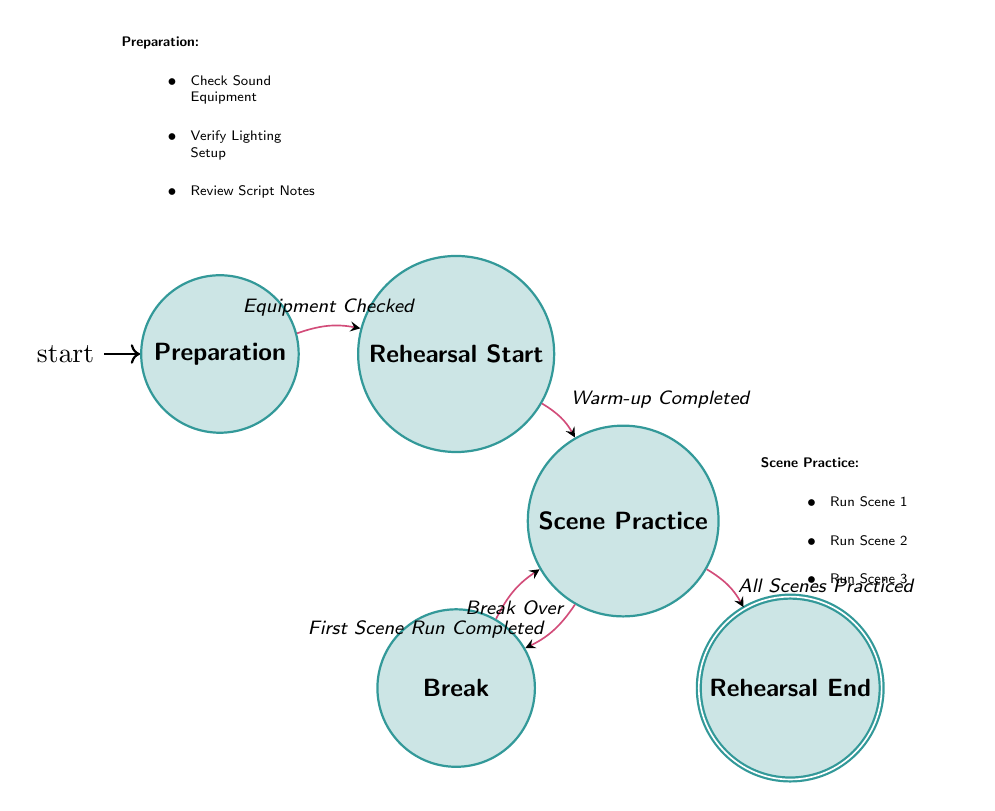What state follows Preparation? The diagram shows a transition from the state "Preparation" to the state "Rehearsal Start," indicating that "Rehearsal Start" follows "Preparation."
Answer: Rehearsal Start How many actions are listed in the Scene Practice state? The "Scene Practice" state contains three actions: "Run Scene 1," "Run Scene 2," and "Run Scene 3." Therefore, there are three actions in the state.
Answer: Three What is the trigger for transitioning from Scene Practice to Break? The transition from "Scene Practice" to "Break" is triggered by the event "First Scene Run Completed," as denoted in the diagram.
Answer: First Scene Run Completed What state comes after Break? According to the diagram, the state that follows "Break" is "Scene Practice," as indicated by the transition triggered by "Break Over."
Answer: Scene Practice How many states are in the diagram? By counting the labeled state nodes in the diagram, we see there are five distinct states: "Preparation," "Rehearsal Start," "Scene Practice," "Break," and "Rehearsal End."
Answer: Five What actions occur during the Break state? The actions listed in the "Break" state are "Water Break" and "Discuss Performance," which show what happens during this state.
Answer: Water Break, Discuss Performance What is the final state of the rehearsal process? The diagram indicates that the final state of the rehearsal process is "Rehearsal End," which is the accepting state in this finite state machine.
Answer: Rehearsal End What is required to transition to Rehearsal End? The transition to "Rehearsal End" occurs after all scenes have been practiced, which is signified by the trigger "All Scenes Practiced."
Answer: All Scenes Practiced What state is reached after Warm-up Completed? The diagram specifies that after the event "Warm-up Completed," the state transitioned to is "Scene Practice."
Answer: Scene Practice 